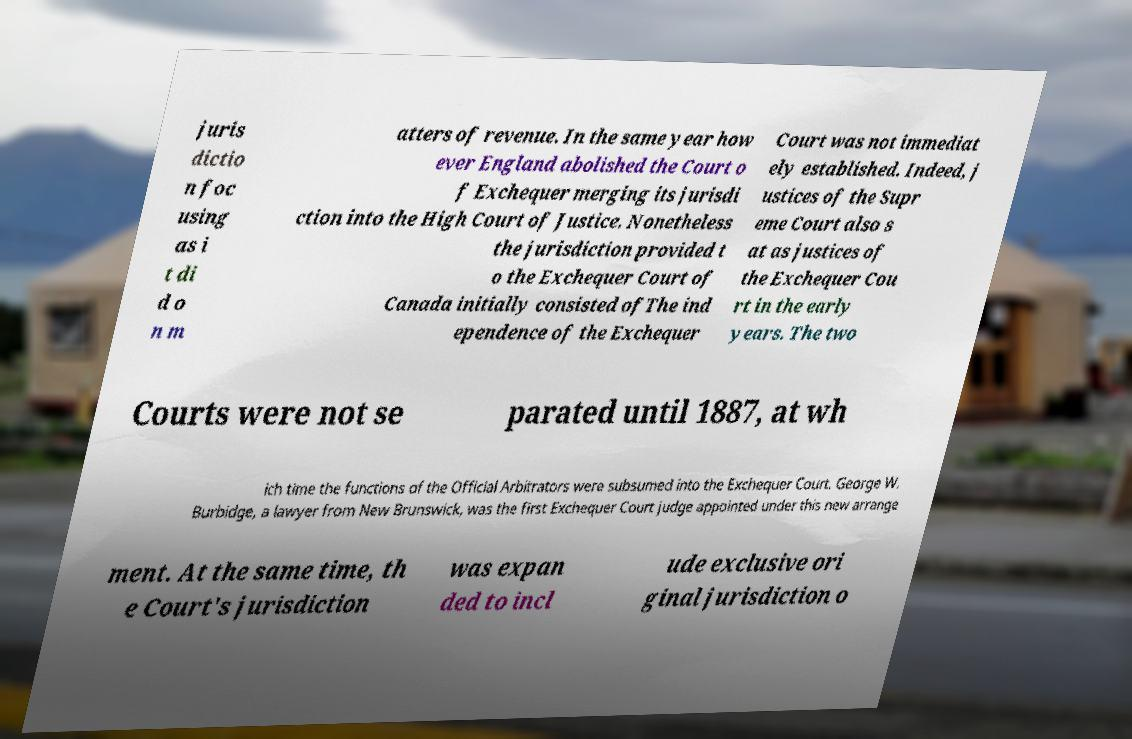Please identify and transcribe the text found in this image. juris dictio n foc using as i t di d o n m atters of revenue. In the same year how ever England abolished the Court o f Exchequer merging its jurisdi ction into the High Court of Justice. Nonetheless the jurisdiction provided t o the Exchequer Court of Canada initially consisted ofThe ind ependence of the Exchequer Court was not immediat ely established. Indeed, j ustices of the Supr eme Court also s at as justices of the Exchequer Cou rt in the early years. The two Courts were not se parated until 1887, at wh ich time the functions of the Official Arbitrators were subsumed into the Exchequer Court. George W. Burbidge, a lawyer from New Brunswick, was the first Exchequer Court judge appointed under this new arrange ment. At the same time, th e Court's jurisdiction was expan ded to incl ude exclusive ori ginal jurisdiction o 